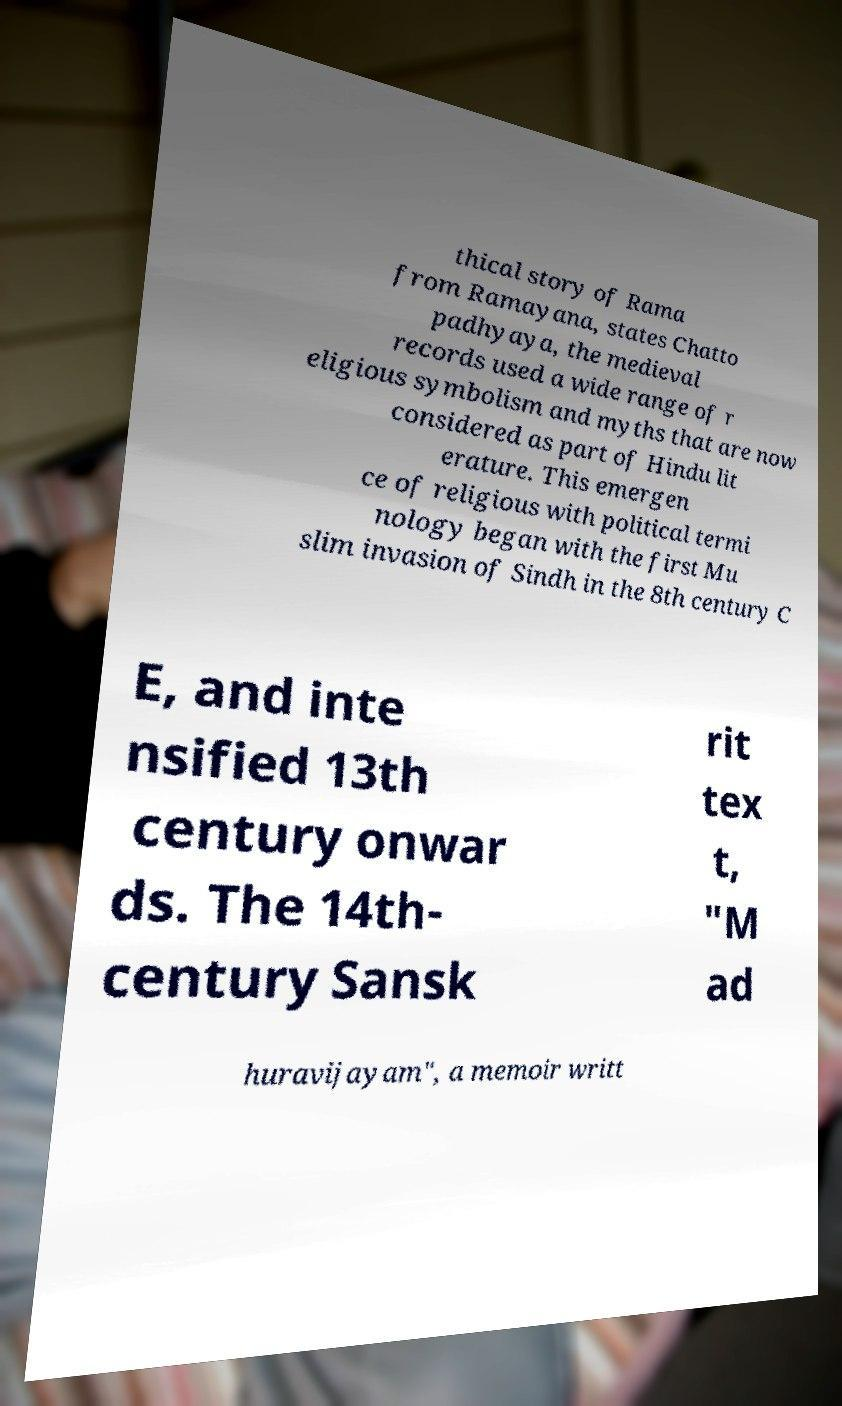Please identify and transcribe the text found in this image. thical story of Rama from Ramayana, states Chatto padhyaya, the medieval records used a wide range of r eligious symbolism and myths that are now considered as part of Hindu lit erature. This emergen ce of religious with political termi nology began with the first Mu slim invasion of Sindh in the 8th century C E, and inte nsified 13th century onwar ds. The 14th- century Sansk rit tex t, "M ad huravijayam", a memoir writt 